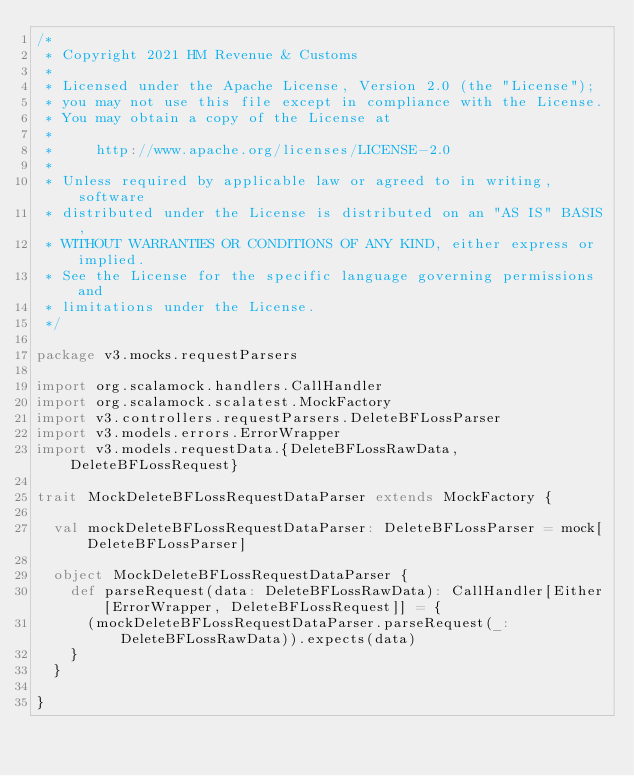<code> <loc_0><loc_0><loc_500><loc_500><_Scala_>/*
 * Copyright 2021 HM Revenue & Customs
 *
 * Licensed under the Apache License, Version 2.0 (the "License");
 * you may not use this file except in compliance with the License.
 * You may obtain a copy of the License at
 *
 *     http://www.apache.org/licenses/LICENSE-2.0
 *
 * Unless required by applicable law or agreed to in writing, software
 * distributed under the License is distributed on an "AS IS" BASIS,
 * WITHOUT WARRANTIES OR CONDITIONS OF ANY KIND, either express or implied.
 * See the License for the specific language governing permissions and
 * limitations under the License.
 */

package v3.mocks.requestParsers

import org.scalamock.handlers.CallHandler
import org.scalamock.scalatest.MockFactory
import v3.controllers.requestParsers.DeleteBFLossParser
import v3.models.errors.ErrorWrapper
import v3.models.requestData.{DeleteBFLossRawData, DeleteBFLossRequest}

trait MockDeleteBFLossRequestDataParser extends MockFactory {

  val mockDeleteBFLossRequestDataParser: DeleteBFLossParser = mock[DeleteBFLossParser]

  object MockDeleteBFLossRequestDataParser {
    def parseRequest(data: DeleteBFLossRawData): CallHandler[Either[ErrorWrapper, DeleteBFLossRequest]] = {
      (mockDeleteBFLossRequestDataParser.parseRequest(_: DeleteBFLossRawData)).expects(data)
    }
  }

}
</code> 